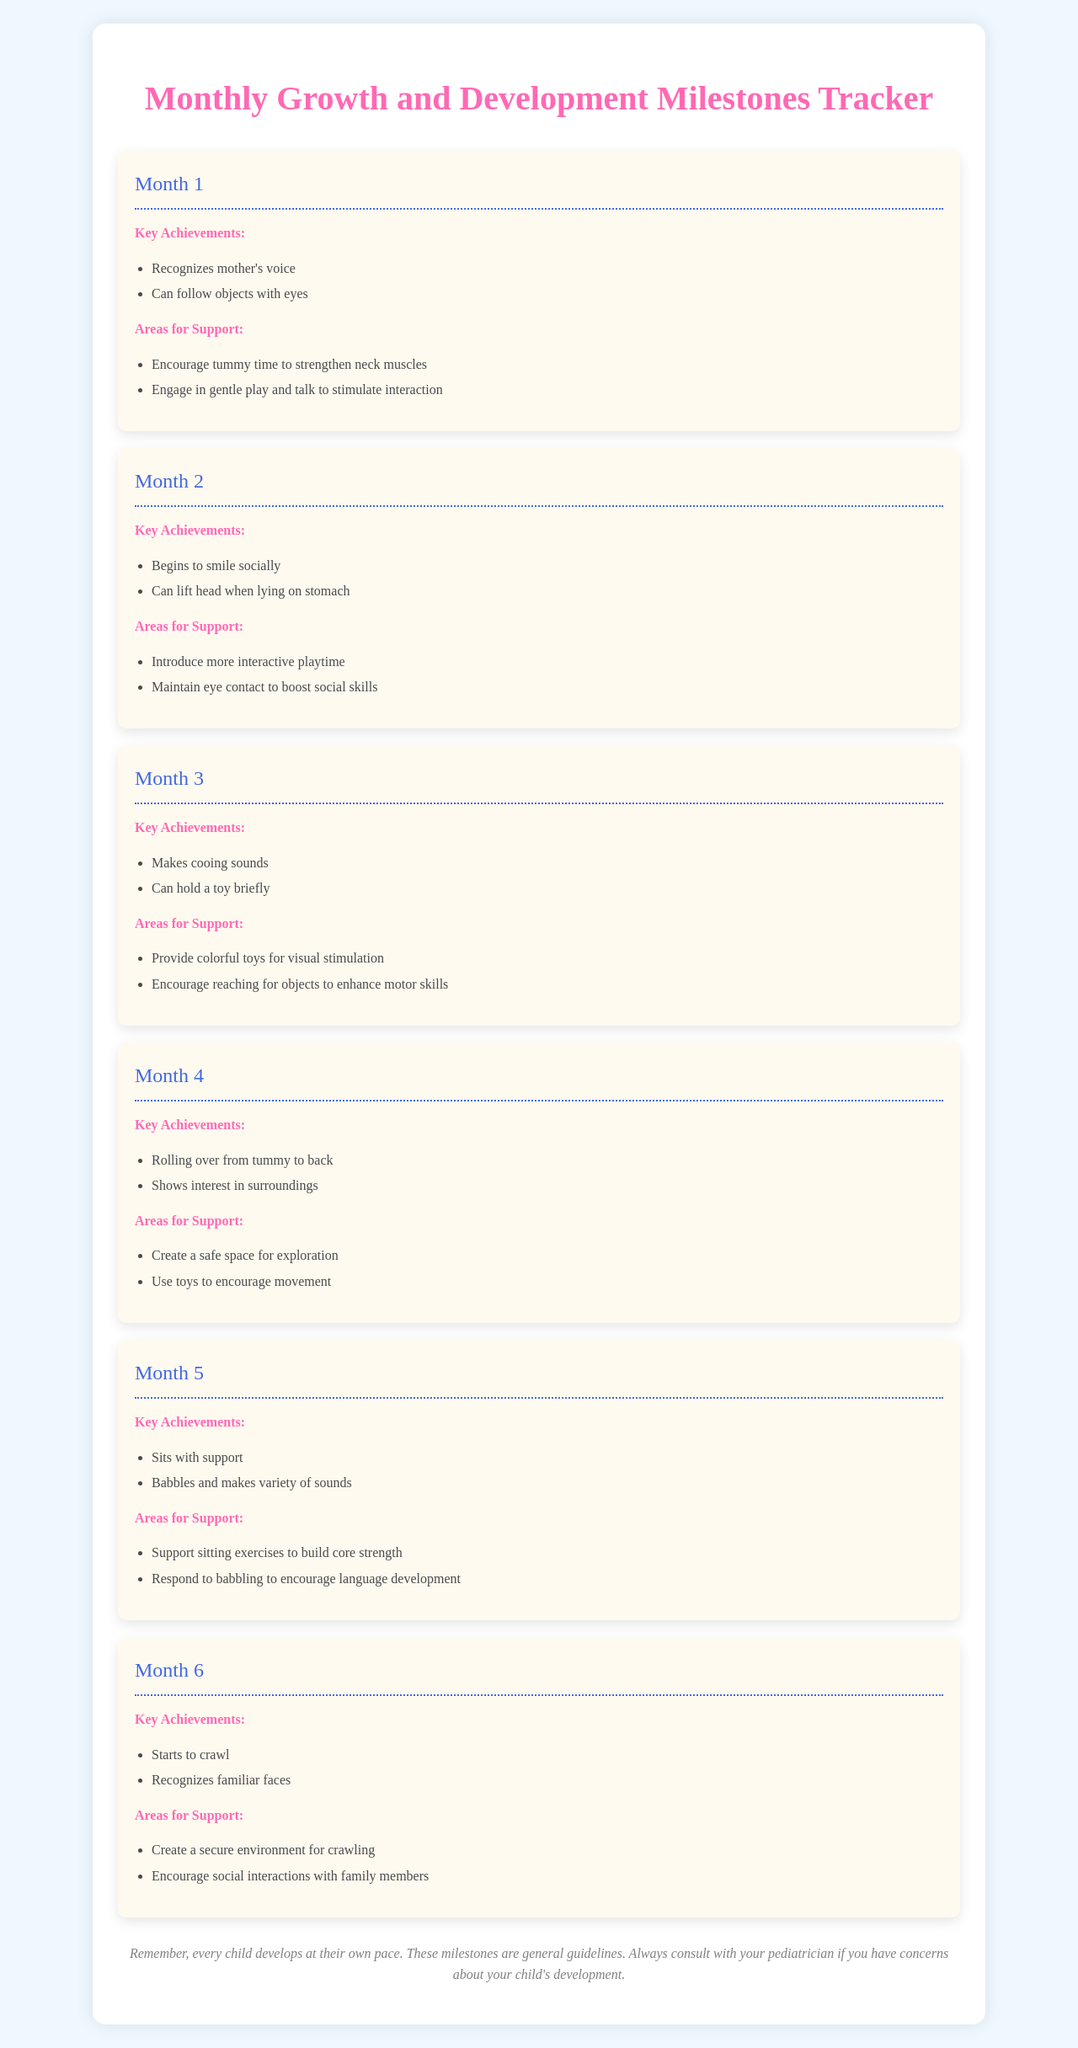what are the key achievements for Month 1? The document lists key achievements for Month 1, which include recognizing mother's voice and following objects with eyes.
Answer: Recognizes mother's voice, Can follow objects with eyes what are areas for support in Month 3? The areas for support outlined in Month 3 are providing colorful toys for visual stimulation and encouraging reaching for objects to enhance motor skills.
Answer: Provide colorful toys for visual stimulation, Encourage reaching for objects to enhance motor skills how many months are covered in the tracker? The document outlines monthly milestones up to Month 6, indicating a total of 6 months are covered.
Answer: 6 which month shows the milestone of starting to crawl? The tracker indicates that starting to crawl is a key achievement listed under Month 6.
Answer: Month 6 what is a recommended support for Month 5? The document suggests supporting sitting exercises to build core strength and responding to babbling to encourage language development for Month 5.
Answer: Support sitting exercises to build core strength what is the main message in the nurse note? The nurse note emphasizes that every child develops at their own pace and suggests consulting a pediatrician if there are concerns about development.
Answer: Every child develops at their own pace which key achievement is observed at Month 4? The significant milestone for Month 4 includes rolling over from tummy to back and showing interest in surroundings.
Answer: Rolling over from tummy to back, Shows interest in surroundings 